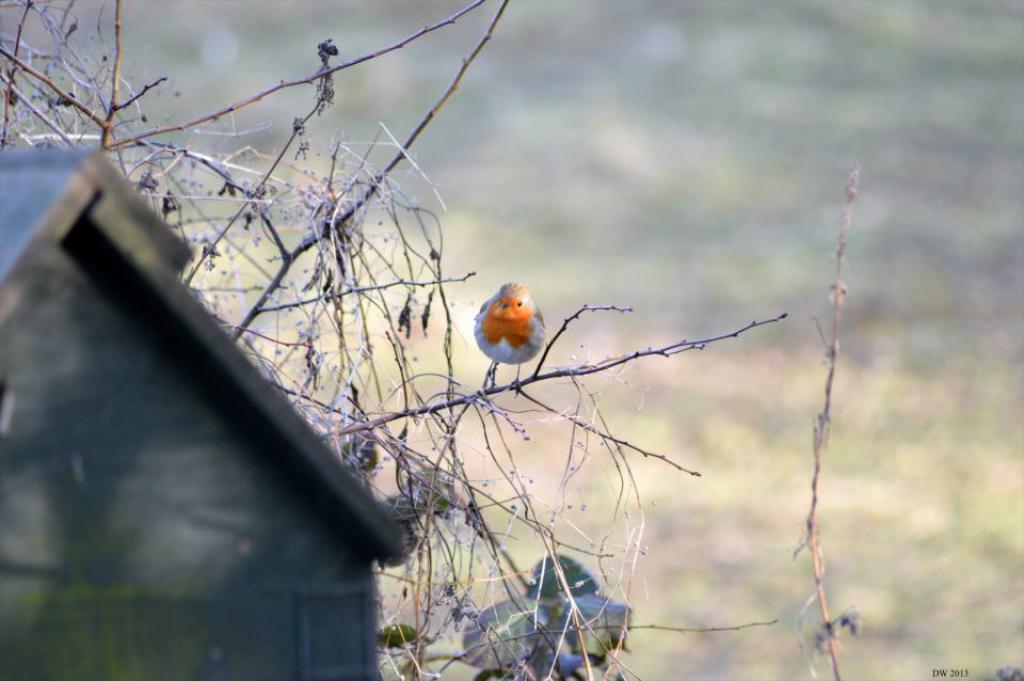Describe this image in one or two sentences. Here we can see bird standing on stem and we can see sky with clouds. 